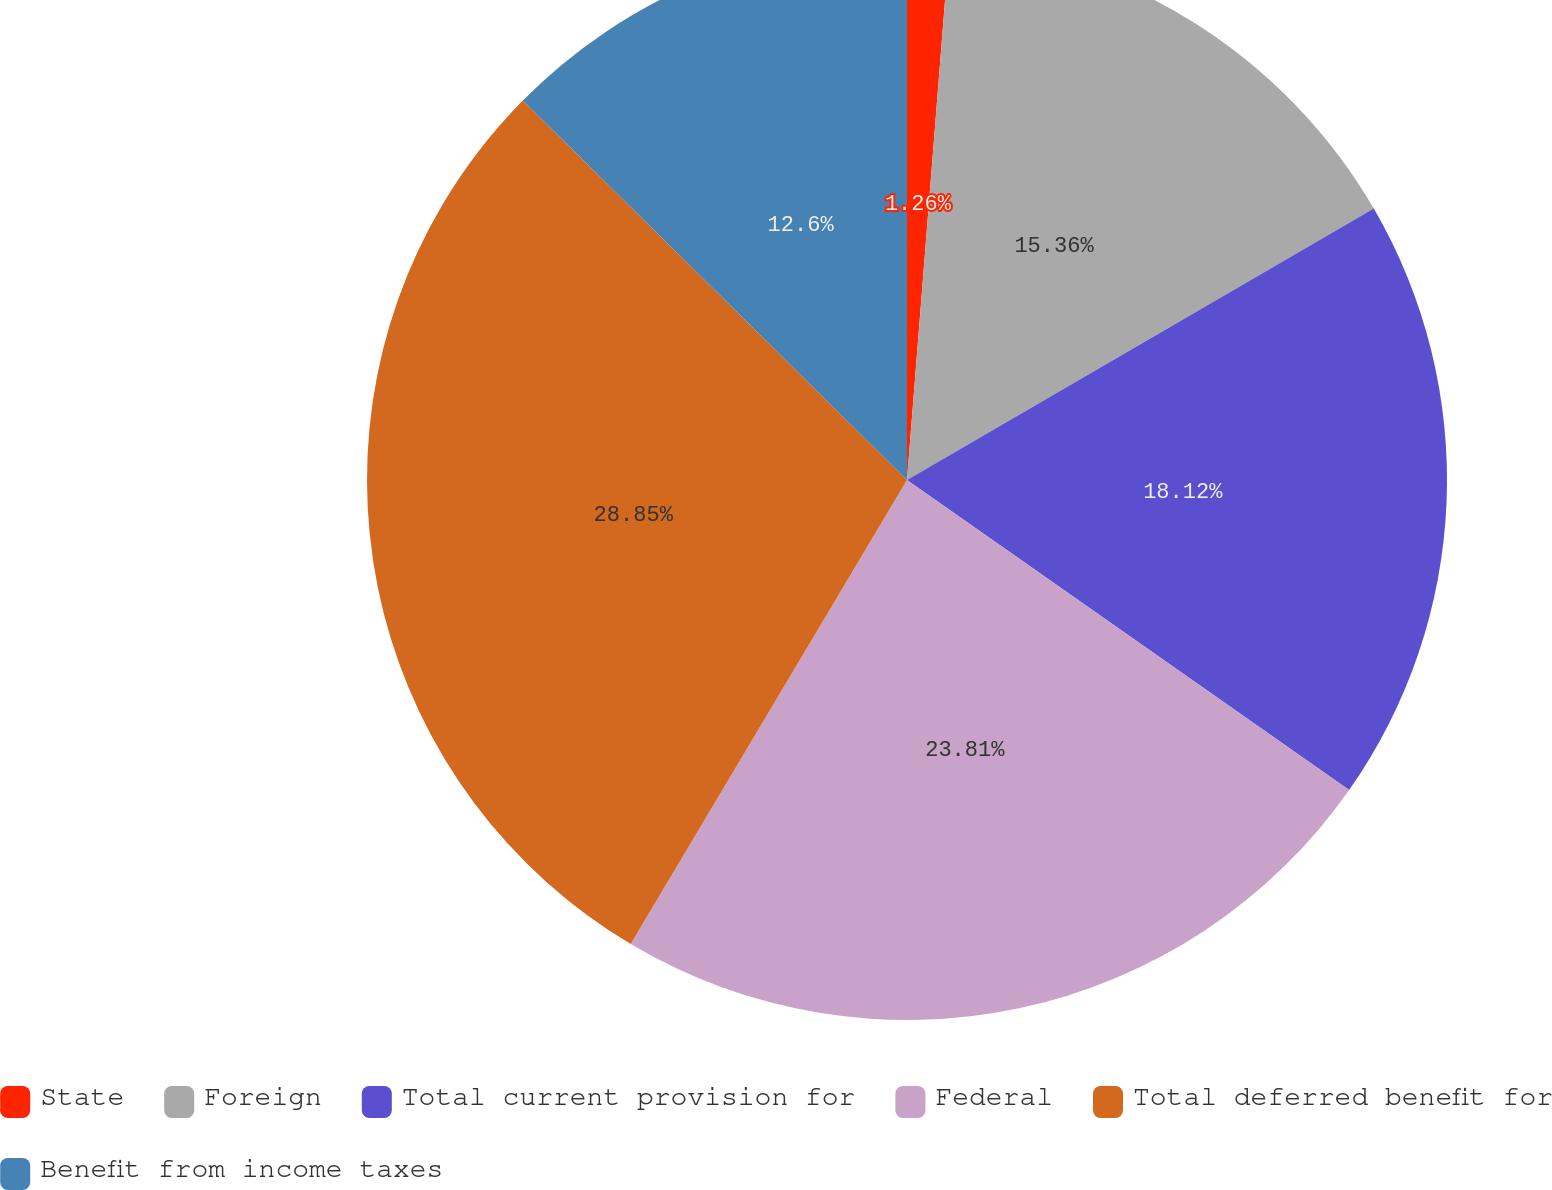<chart> <loc_0><loc_0><loc_500><loc_500><pie_chart><fcel>State<fcel>Foreign<fcel>Total current provision for<fcel>Federal<fcel>Total deferred benefit for<fcel>Benefit from income taxes<nl><fcel>1.26%<fcel>15.36%<fcel>18.12%<fcel>23.82%<fcel>28.86%<fcel>12.6%<nl></chart> 